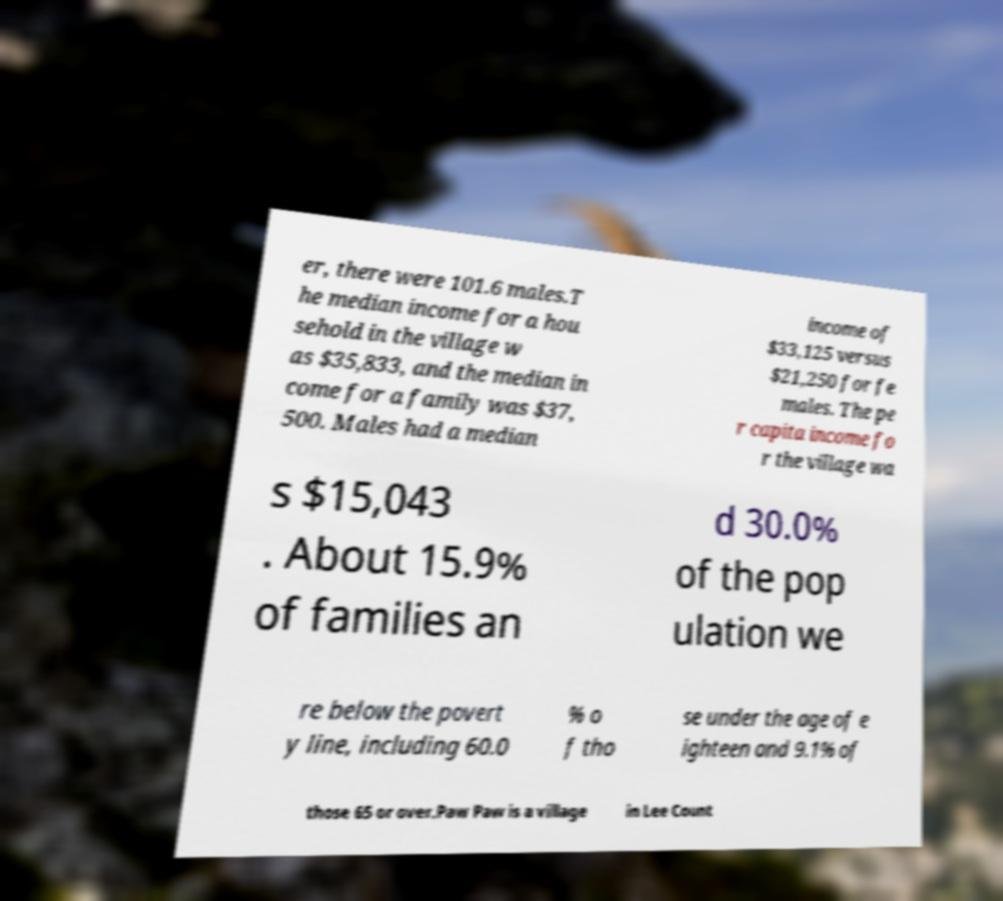Can you accurately transcribe the text from the provided image for me? er, there were 101.6 males.T he median income for a hou sehold in the village w as $35,833, and the median in come for a family was $37, 500. Males had a median income of $33,125 versus $21,250 for fe males. The pe r capita income fo r the village wa s $15,043 . About 15.9% of families an d 30.0% of the pop ulation we re below the povert y line, including 60.0 % o f tho se under the age of e ighteen and 9.1% of those 65 or over.Paw Paw is a village in Lee Count 